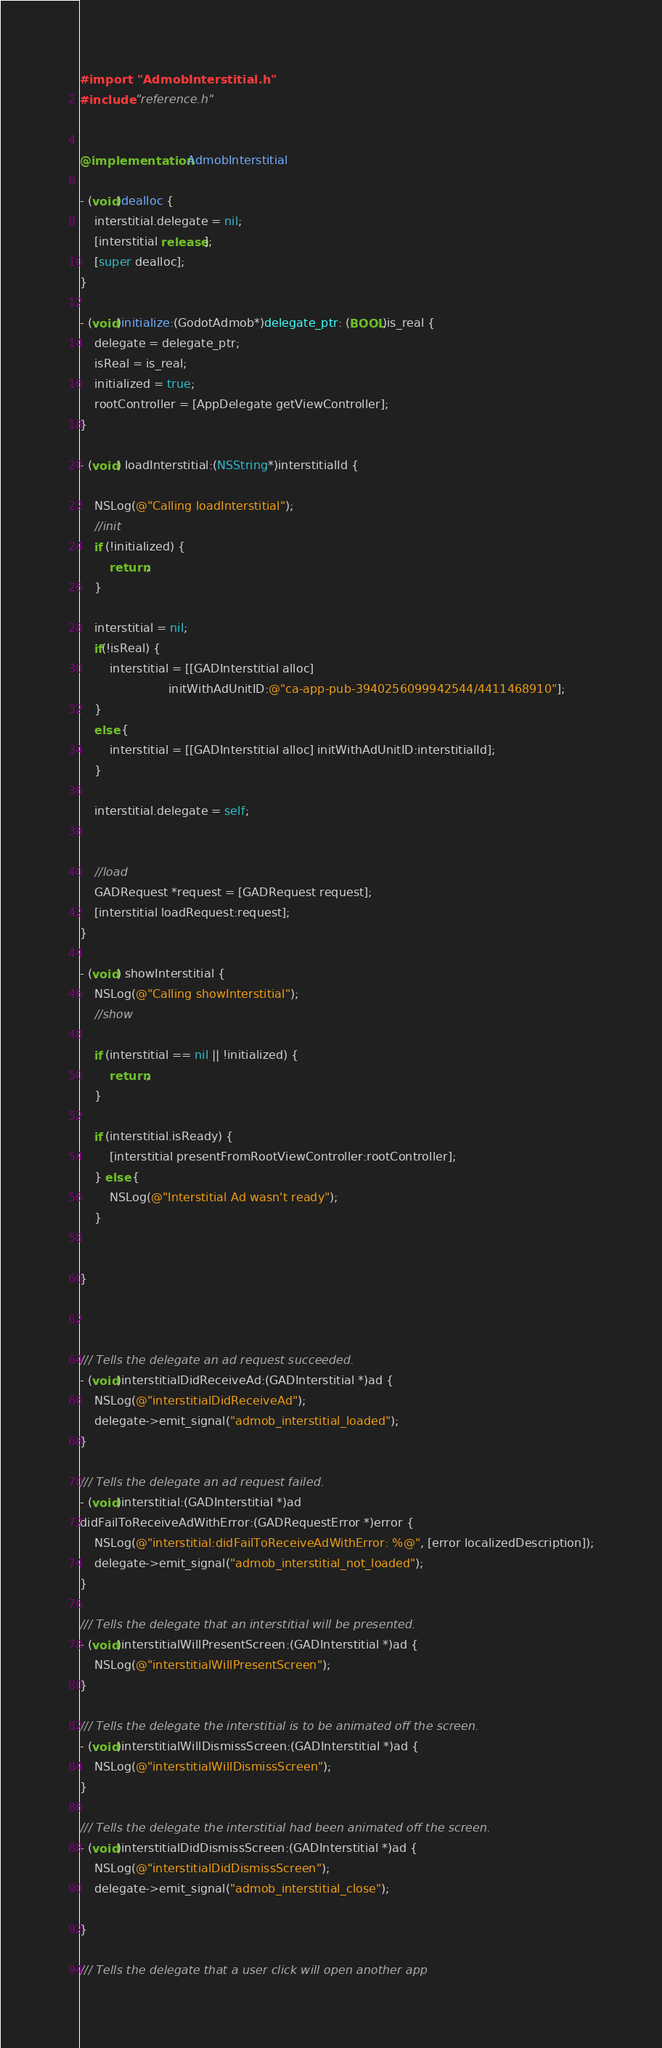Convert code to text. <code><loc_0><loc_0><loc_500><loc_500><_ObjectiveC_>#import "AdmobInterstitial.h"
#include "reference.h"


@implementation AdmobInterstitial

- (void)dealloc {
    interstitial.delegate = nil;
    [interstitial release];
    [super dealloc];
}

- (void)initialize:(GodotAdmob*)delegate_ptr: (BOOL)is_real {
    delegate = delegate_ptr;
    isReal = is_real;
    initialized = true;
    rootController = [AppDelegate getViewController];
}

- (void) loadInterstitial:(NSString*)interstitialId {
    
    NSLog(@"Calling loadInterstitial");
    //init
    if (!initialized) {
        return;
    }
    
    interstitial = nil;
    if(!isReal) {
        interstitial = [[GADInterstitial alloc]
                        initWithAdUnitID:@"ca-app-pub-3940256099942544/4411468910"];
    }
    else {
        interstitial = [[GADInterstitial alloc] initWithAdUnitID:interstitialId];
    }
    
    interstitial.delegate = self;
    
    
    //load
    GADRequest *request = [GADRequest request];
    [interstitial loadRequest:request];
}

- (void) showInterstitial {
    NSLog(@"Calling showInterstitial");
    //show
    
    if (interstitial == nil || !initialized) {
        return;
    }
    
    if (interstitial.isReady) {
        [interstitial presentFromRootViewController:rootController];
    } else {
        NSLog(@"Interstitial Ad wasn't ready");
    }
    
    
}



/// Tells the delegate an ad request succeeded.
- (void)interstitialDidReceiveAd:(GADInterstitial *)ad {
    NSLog(@"interstitialDidReceiveAd");
    delegate->emit_signal("admob_interstitial_loaded");
}

/// Tells the delegate an ad request failed.
- (void)interstitial:(GADInterstitial *)ad
didFailToReceiveAdWithError:(GADRequestError *)error {
    NSLog(@"interstitial:didFailToReceiveAdWithError: %@", [error localizedDescription]);
    delegate->emit_signal("admob_interstitial_not_loaded");
}

/// Tells the delegate that an interstitial will be presented.
- (void)interstitialWillPresentScreen:(GADInterstitial *)ad {
    NSLog(@"interstitialWillPresentScreen");
}

/// Tells the delegate the interstitial is to be animated off the screen.
- (void)interstitialWillDismissScreen:(GADInterstitial *)ad {
    NSLog(@"interstitialWillDismissScreen");
}

/// Tells the delegate the interstitial had been animated off the screen.
- (void)interstitialDidDismissScreen:(GADInterstitial *)ad {
    NSLog(@"interstitialDidDismissScreen");
    delegate->emit_signal("admob_interstitial_close");
 
}

/// Tells the delegate that a user click will open another app</code> 